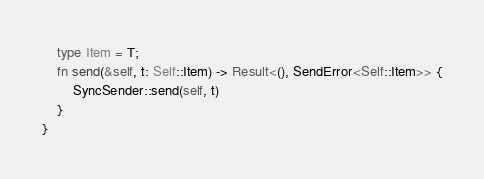<code> <loc_0><loc_0><loc_500><loc_500><_Rust_>    type Item = T;
    fn send(&self, t: Self::Item) -> Result<(), SendError<Self::Item>> {
        SyncSender::send(self, t)
    }
}
</code> 